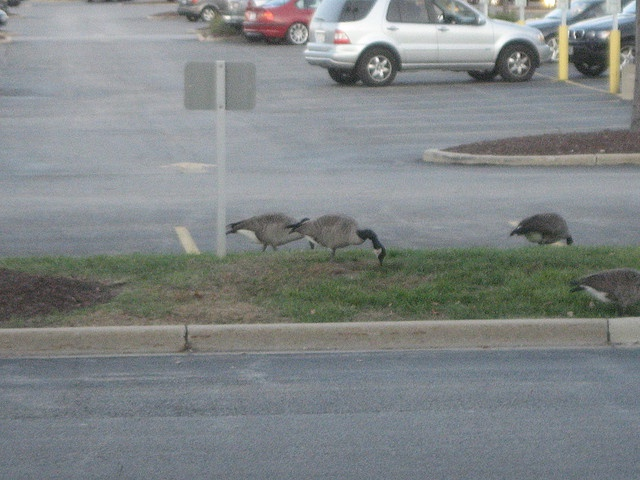Describe the objects in this image and their specific colors. I can see car in gray, lightgray, darkgray, and black tones, car in gray, black, darkgray, and lightgray tones, car in gray, brown, darkgray, and lightgray tones, bird in gray and black tones, and bird in gray, black, and purple tones in this image. 